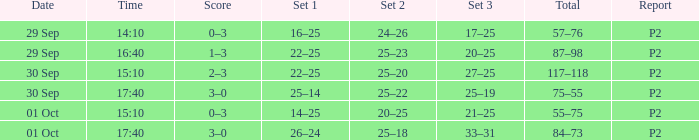For a date of 29 Sep and a time of 16:40, what is the corresponding Set 3? 20–25. 